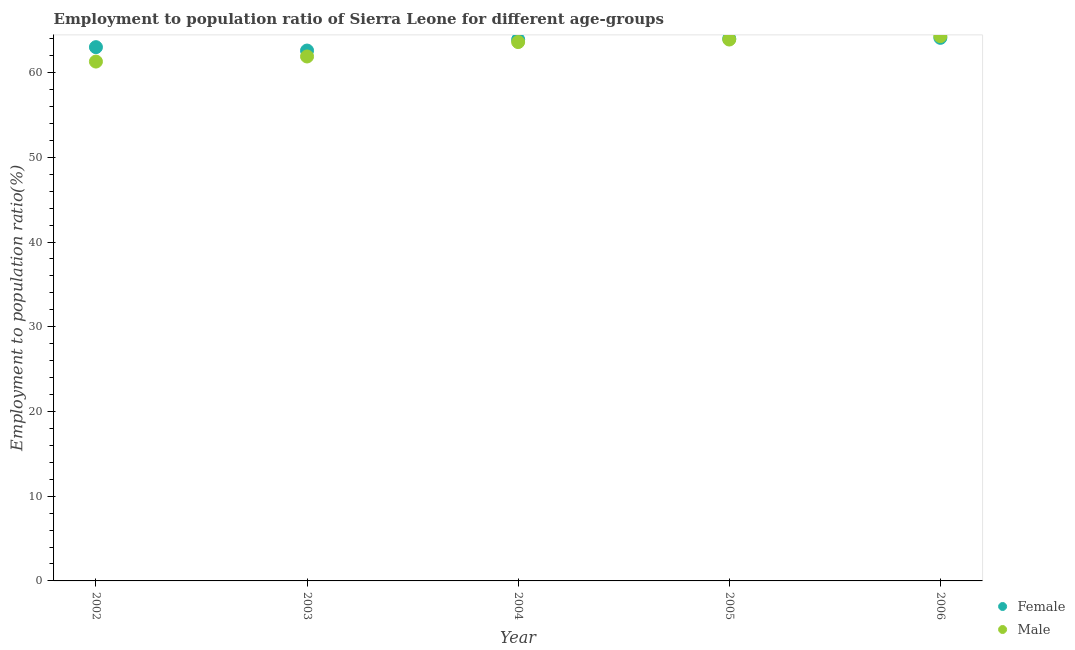Is the number of dotlines equal to the number of legend labels?
Ensure brevity in your answer.  Yes. What is the employment to population ratio(male) in 2002?
Your response must be concise. 61.3. Across all years, what is the maximum employment to population ratio(male)?
Your answer should be compact. 64.3. Across all years, what is the minimum employment to population ratio(male)?
Keep it short and to the point. 61.3. In which year was the employment to population ratio(female) maximum?
Give a very brief answer. 2006. In which year was the employment to population ratio(female) minimum?
Keep it short and to the point. 2003. What is the total employment to population ratio(male) in the graph?
Your response must be concise. 315. What is the difference between the employment to population ratio(male) in 2002 and that in 2003?
Ensure brevity in your answer.  -0.6. What is the average employment to population ratio(female) per year?
Make the answer very short. 63.52. In the year 2004, what is the difference between the employment to population ratio(female) and employment to population ratio(male)?
Provide a succinct answer. 0.3. In how many years, is the employment to population ratio(female) greater than 26 %?
Keep it short and to the point. 5. What is the ratio of the employment to population ratio(female) in 2003 to that in 2004?
Provide a short and direct response. 0.98. Is the employment to population ratio(female) in 2003 less than that in 2006?
Make the answer very short. Yes. What is the difference between the highest and the second highest employment to population ratio(male)?
Your answer should be very brief. 0.4. What is the difference between the highest and the lowest employment to population ratio(male)?
Give a very brief answer. 3. In how many years, is the employment to population ratio(female) greater than the average employment to population ratio(female) taken over all years?
Keep it short and to the point. 3. Is the sum of the employment to population ratio(female) in 2002 and 2004 greater than the maximum employment to population ratio(male) across all years?
Keep it short and to the point. Yes. Does the employment to population ratio(male) monotonically increase over the years?
Your answer should be compact. Yes. How many dotlines are there?
Ensure brevity in your answer.  2. How many years are there in the graph?
Your response must be concise. 5. What is the difference between two consecutive major ticks on the Y-axis?
Keep it short and to the point. 10. Where does the legend appear in the graph?
Give a very brief answer. Bottom right. How are the legend labels stacked?
Make the answer very short. Vertical. What is the title of the graph?
Provide a short and direct response. Employment to population ratio of Sierra Leone for different age-groups. Does "Non-pregnant women" appear as one of the legend labels in the graph?
Your answer should be compact. No. What is the Employment to population ratio(%) in Male in 2002?
Offer a very short reply. 61.3. What is the Employment to population ratio(%) of Female in 2003?
Your answer should be compact. 62.6. What is the Employment to population ratio(%) in Male in 2003?
Your answer should be very brief. 61.9. What is the Employment to population ratio(%) in Female in 2004?
Provide a succinct answer. 63.9. What is the Employment to population ratio(%) in Male in 2004?
Your response must be concise. 63.6. What is the Employment to population ratio(%) in Female in 2005?
Offer a terse response. 64. What is the Employment to population ratio(%) in Male in 2005?
Your response must be concise. 63.9. What is the Employment to population ratio(%) in Female in 2006?
Your response must be concise. 64.1. What is the Employment to population ratio(%) in Male in 2006?
Give a very brief answer. 64.3. Across all years, what is the maximum Employment to population ratio(%) in Female?
Ensure brevity in your answer.  64.1. Across all years, what is the maximum Employment to population ratio(%) in Male?
Your answer should be very brief. 64.3. Across all years, what is the minimum Employment to population ratio(%) in Female?
Provide a short and direct response. 62.6. Across all years, what is the minimum Employment to population ratio(%) in Male?
Offer a very short reply. 61.3. What is the total Employment to population ratio(%) in Female in the graph?
Your answer should be very brief. 317.6. What is the total Employment to population ratio(%) in Male in the graph?
Your answer should be compact. 315. What is the difference between the Employment to population ratio(%) of Female in 2002 and that in 2004?
Provide a short and direct response. -0.9. What is the difference between the Employment to population ratio(%) of Female in 2002 and that in 2005?
Your response must be concise. -1. What is the difference between the Employment to population ratio(%) in Male in 2003 and that in 2004?
Make the answer very short. -1.7. What is the difference between the Employment to population ratio(%) in Female in 2003 and that in 2006?
Keep it short and to the point. -1.5. What is the difference between the Employment to population ratio(%) of Female in 2004 and that in 2005?
Give a very brief answer. -0.1. What is the difference between the Employment to population ratio(%) of Male in 2004 and that in 2005?
Make the answer very short. -0.3. What is the difference between the Employment to population ratio(%) of Female in 2004 and that in 2006?
Make the answer very short. -0.2. What is the difference between the Employment to population ratio(%) in Male in 2004 and that in 2006?
Your response must be concise. -0.7. What is the difference between the Employment to population ratio(%) of Male in 2005 and that in 2006?
Keep it short and to the point. -0.4. What is the difference between the Employment to population ratio(%) of Female in 2002 and the Employment to population ratio(%) of Male in 2004?
Your answer should be very brief. -0.6. What is the difference between the Employment to population ratio(%) in Female in 2002 and the Employment to population ratio(%) in Male in 2005?
Provide a short and direct response. -0.9. What is the difference between the Employment to population ratio(%) of Female in 2003 and the Employment to population ratio(%) of Male in 2006?
Provide a short and direct response. -1.7. What is the difference between the Employment to population ratio(%) of Female in 2004 and the Employment to population ratio(%) of Male in 2005?
Keep it short and to the point. 0. What is the difference between the Employment to population ratio(%) of Female in 2005 and the Employment to population ratio(%) of Male in 2006?
Provide a short and direct response. -0.3. What is the average Employment to population ratio(%) in Female per year?
Your answer should be compact. 63.52. What is the average Employment to population ratio(%) of Male per year?
Give a very brief answer. 63. In the year 2002, what is the difference between the Employment to population ratio(%) in Female and Employment to population ratio(%) in Male?
Your answer should be very brief. 1.7. In the year 2003, what is the difference between the Employment to population ratio(%) of Female and Employment to population ratio(%) of Male?
Provide a short and direct response. 0.7. In the year 2004, what is the difference between the Employment to population ratio(%) of Female and Employment to population ratio(%) of Male?
Make the answer very short. 0.3. In the year 2005, what is the difference between the Employment to population ratio(%) of Female and Employment to population ratio(%) of Male?
Give a very brief answer. 0.1. In the year 2006, what is the difference between the Employment to population ratio(%) in Female and Employment to population ratio(%) in Male?
Offer a terse response. -0.2. What is the ratio of the Employment to population ratio(%) in Female in 2002 to that in 2003?
Make the answer very short. 1.01. What is the ratio of the Employment to population ratio(%) in Male in 2002 to that in 2003?
Give a very brief answer. 0.99. What is the ratio of the Employment to population ratio(%) in Female in 2002 to that in 2004?
Your answer should be very brief. 0.99. What is the ratio of the Employment to population ratio(%) of Male in 2002 to that in 2004?
Your answer should be very brief. 0.96. What is the ratio of the Employment to population ratio(%) of Female in 2002 to that in 2005?
Keep it short and to the point. 0.98. What is the ratio of the Employment to population ratio(%) in Male in 2002 to that in 2005?
Offer a terse response. 0.96. What is the ratio of the Employment to population ratio(%) in Female in 2002 to that in 2006?
Keep it short and to the point. 0.98. What is the ratio of the Employment to population ratio(%) in Male in 2002 to that in 2006?
Give a very brief answer. 0.95. What is the ratio of the Employment to population ratio(%) of Female in 2003 to that in 2004?
Provide a succinct answer. 0.98. What is the ratio of the Employment to population ratio(%) in Male in 2003 to that in 2004?
Keep it short and to the point. 0.97. What is the ratio of the Employment to population ratio(%) of Female in 2003 to that in 2005?
Provide a succinct answer. 0.98. What is the ratio of the Employment to population ratio(%) of Male in 2003 to that in 2005?
Offer a terse response. 0.97. What is the ratio of the Employment to population ratio(%) in Female in 2003 to that in 2006?
Offer a very short reply. 0.98. What is the ratio of the Employment to population ratio(%) in Male in 2003 to that in 2006?
Make the answer very short. 0.96. What is the ratio of the Employment to population ratio(%) of Male in 2004 to that in 2005?
Make the answer very short. 1. What is the ratio of the Employment to population ratio(%) of Male in 2004 to that in 2006?
Make the answer very short. 0.99. What is the difference between the highest and the second highest Employment to population ratio(%) of Female?
Offer a very short reply. 0.1. What is the difference between the highest and the lowest Employment to population ratio(%) in Female?
Ensure brevity in your answer.  1.5. What is the difference between the highest and the lowest Employment to population ratio(%) in Male?
Provide a succinct answer. 3. 